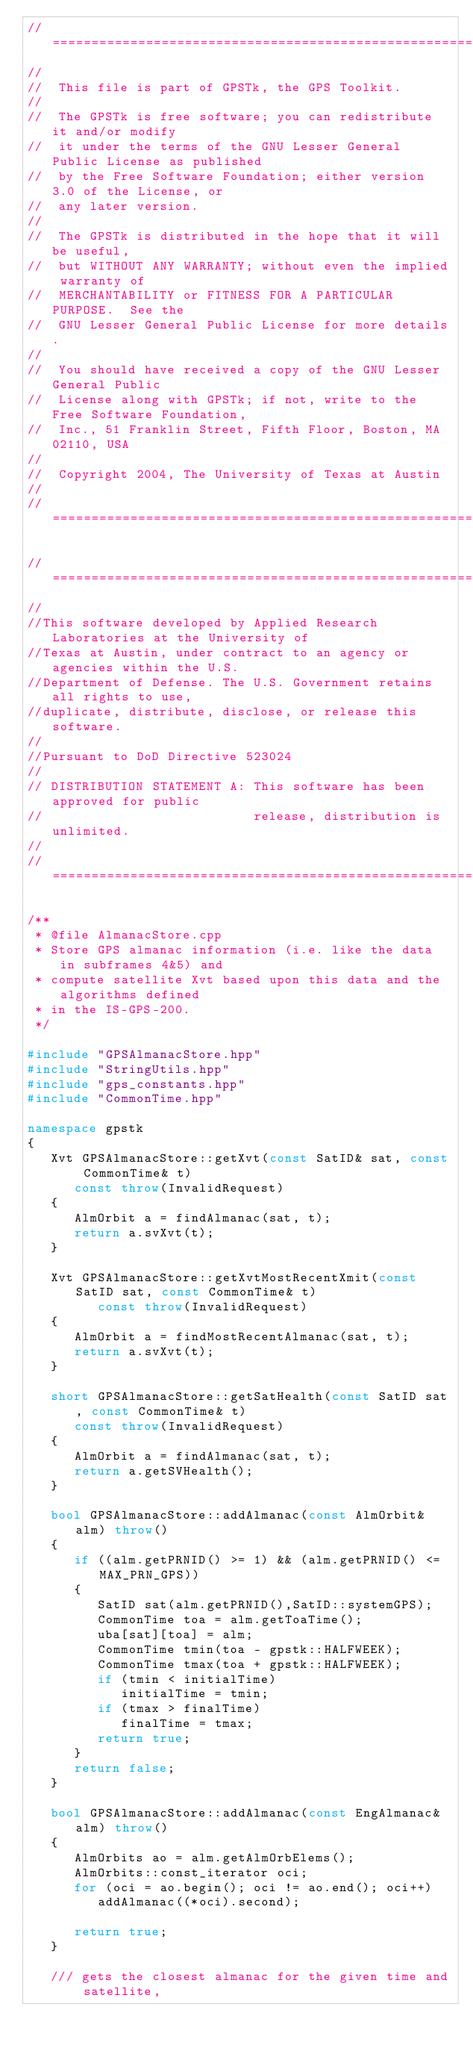Convert code to text. <code><loc_0><loc_0><loc_500><loc_500><_C++_>//============================================================================
//
//  This file is part of GPSTk, the GPS Toolkit.
//
//  The GPSTk is free software; you can redistribute it and/or modify
//  it under the terms of the GNU Lesser General Public License as published
//  by the Free Software Foundation; either version 3.0 of the License, or
//  any later version.
//
//  The GPSTk is distributed in the hope that it will be useful,
//  but WITHOUT ANY WARRANTY; without even the implied warranty of
//  MERCHANTABILITY or FITNESS FOR A PARTICULAR PURPOSE.  See the
//  GNU Lesser General Public License for more details.
//
//  You should have received a copy of the GNU Lesser General Public
//  License along with GPSTk; if not, write to the Free Software Foundation,
//  Inc., 51 Franklin Street, Fifth Floor, Boston, MA 02110, USA
//  
//  Copyright 2004, The University of Texas at Austin
//
//============================================================================

//============================================================================
//
//This software developed by Applied Research Laboratories at the University of
//Texas at Austin, under contract to an agency or agencies within the U.S. 
//Department of Defense. The U.S. Government retains all rights to use,
//duplicate, distribute, disclose, or release this software. 
//
//Pursuant to DoD Directive 523024 
//
// DISTRIBUTION STATEMENT A: This software has been approved for public 
//                           release, distribution is unlimited.
//
//=============================================================================

/**
 * @file AlmanacStore.cpp
 * Store GPS almanac information (i.e. like the data in subframes 4&5) and 
 * compute satellite Xvt based upon this data and the algorithms defined
 * in the IS-GPS-200.
 */

#include "GPSAlmanacStore.hpp"
#include "StringUtils.hpp"
#include "gps_constants.hpp"
#include "CommonTime.hpp"

namespace gpstk
{
   Xvt GPSAlmanacStore::getXvt(const SatID& sat, const CommonTime& t)
      const throw(InvalidRequest)
   {
      AlmOrbit a = findAlmanac(sat, t);
      return a.svXvt(t);
   }

   Xvt GPSAlmanacStore::getXvtMostRecentXmit(const SatID sat, const CommonTime& t) 
         const throw(InvalidRequest)
   {
      AlmOrbit a = findMostRecentAlmanac(sat, t);
      return a.svXvt(t);
   }
   
   short GPSAlmanacStore::getSatHealth(const SatID sat, const CommonTime& t)
      const throw(InvalidRequest)
   {
      AlmOrbit a = findAlmanac(sat, t);
      return a.getSVHealth();
   }

   bool GPSAlmanacStore::addAlmanac(const AlmOrbit& alm) throw()
   {
      if ((alm.getPRNID() >= 1) && (alm.getPRNID() <= MAX_PRN_GPS))
      {
         SatID sat(alm.getPRNID(),SatID::systemGPS);
         CommonTime toa = alm.getToaTime();
         uba[sat][toa] = alm;
         CommonTime tmin(toa - gpstk::HALFWEEK);
         CommonTime tmax(toa + gpstk::HALFWEEK);
         if (tmin < initialTime)
            initialTime = tmin;
         if (tmax > finalTime)
            finalTime = tmax;
         return true;
      }
      return false;
   }

   bool GPSAlmanacStore::addAlmanac(const EngAlmanac& alm) throw()
   {
      AlmOrbits ao = alm.getAlmOrbElems();
      AlmOrbits::const_iterator oci;
      for (oci = ao.begin(); oci != ao.end(); oci++)
         addAlmanac((*oci).second);

      return true;
   }

   /// gets the closest almanac for the given time and satellite,</code> 